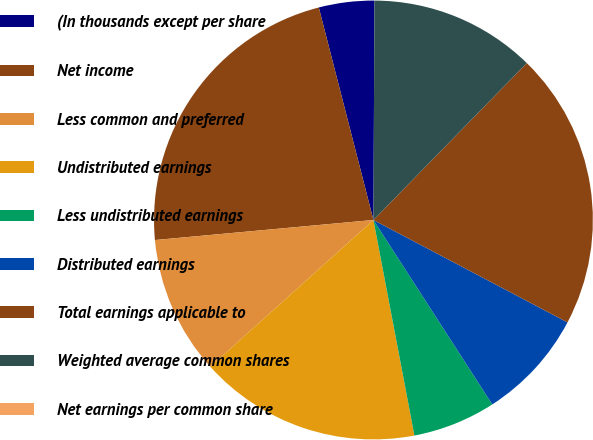Convert chart. <chart><loc_0><loc_0><loc_500><loc_500><pie_chart><fcel>(In thousands except per share<fcel>Net income<fcel>Less common and preferred<fcel>Undistributed earnings<fcel>Less undistributed earnings<fcel>Distributed earnings<fcel>Total earnings applicable to<fcel>Weighted average common shares<fcel>Net earnings per common share<nl><fcel>4.08%<fcel>22.45%<fcel>10.2%<fcel>16.33%<fcel>6.12%<fcel>8.16%<fcel>20.41%<fcel>12.24%<fcel>0.0%<nl></chart> 